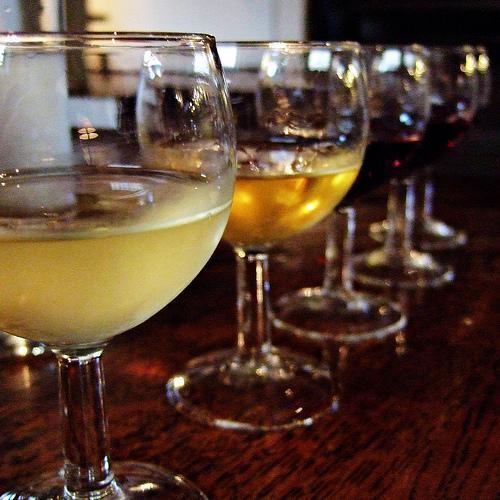How many glasses are photographed?
Give a very brief answer. 5. 